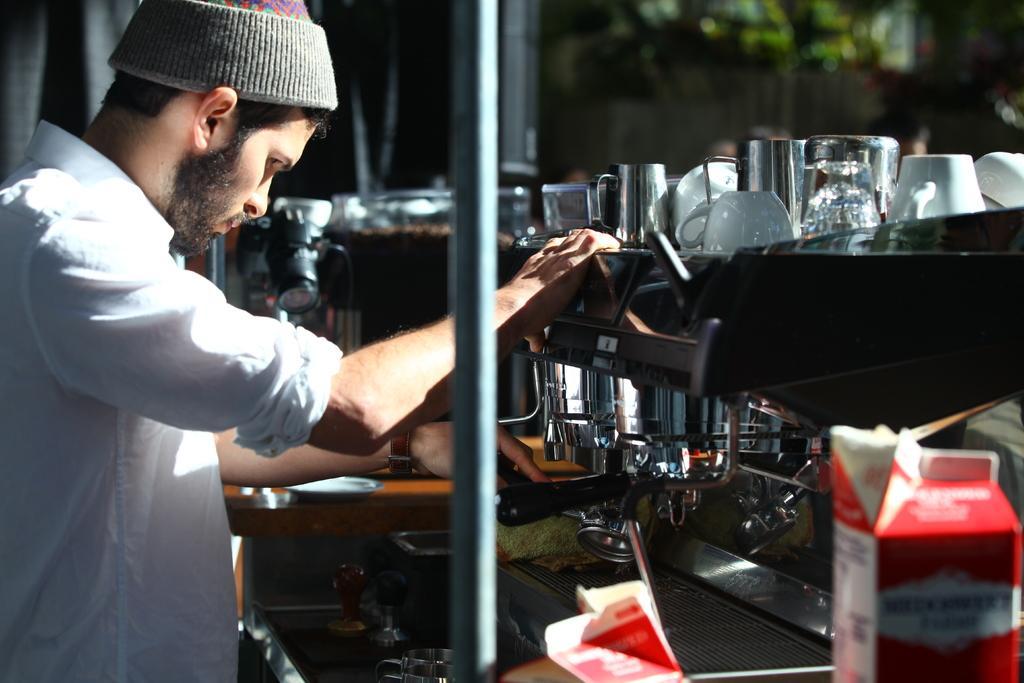In one or two sentences, can you explain what this image depicts? To the left side of the image there is a person. In front of him there is a coffee machine with glasses and cups on it. At the bottom of the image there is a red color tetra pack. 